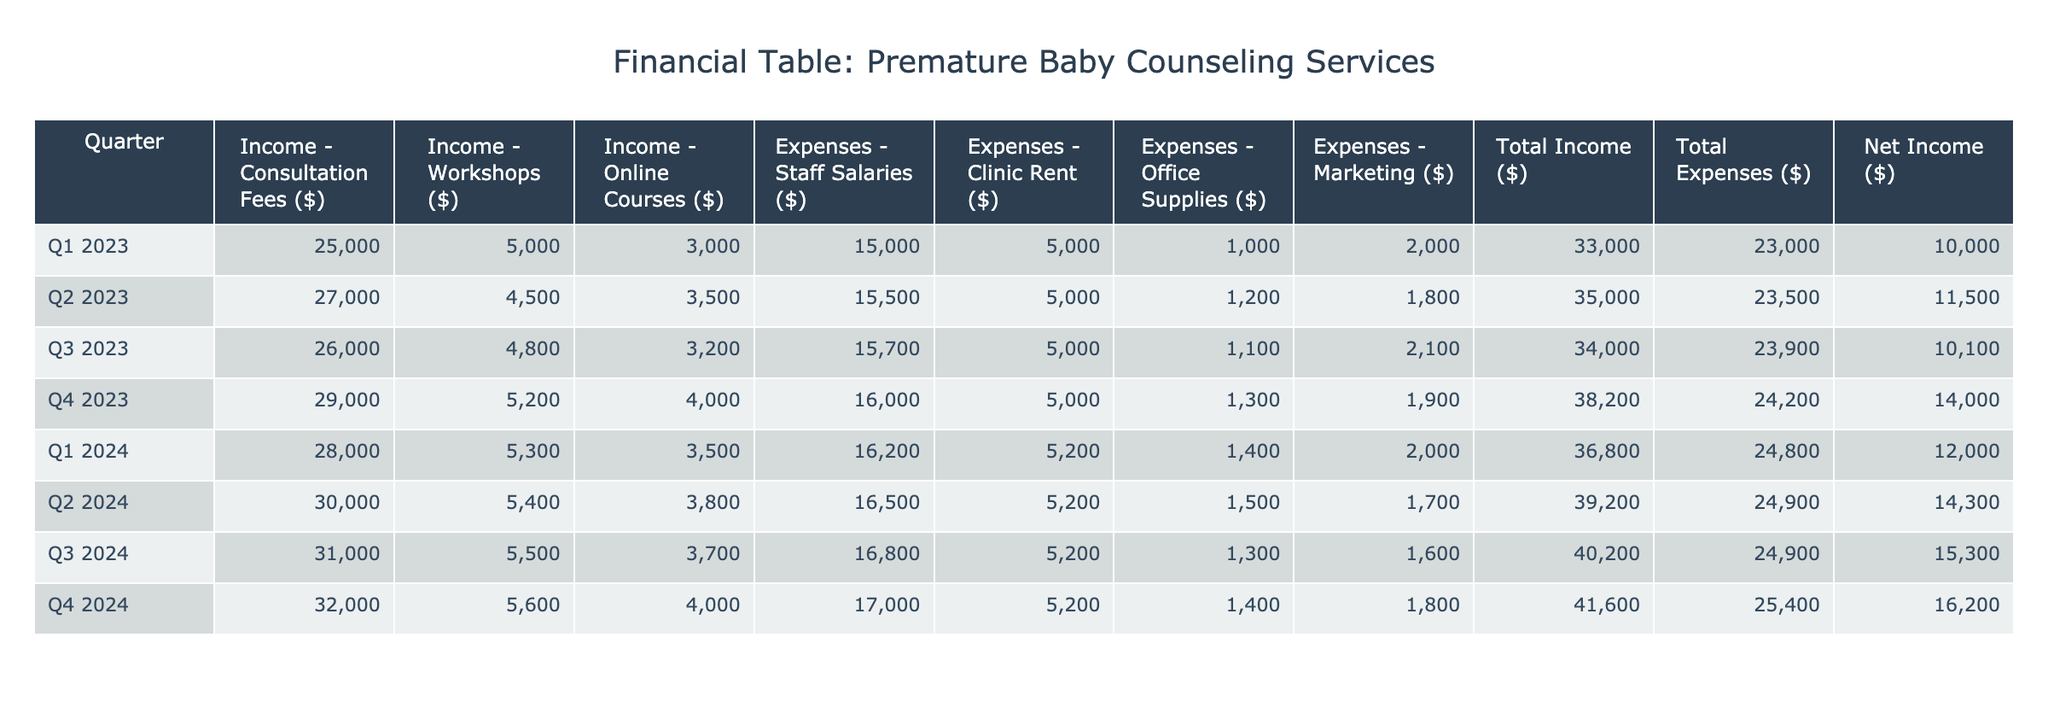What was the total income in Q3 2023? To find the total income in Q3 2023, look at the column labeled "Total Income ($)" and find the row for Q3 2023. The total income listed is 34000.
Answer: 34000 In which quarter did the counseling services have the highest net income? To find the highest net income, compare values in the "Net Income ($)" column across all quarters. The highest value is 16200 in Q4 2024.
Answer: Q4 2024 What is the average expense on office supplies across all quarters? Add the office supplies expenses for each quarter: (1000 + 1200 + 1100 + 1300 + 1400 + 1500 + 1300 + 1400) = 10500. There are 8 quarters, so divide by 8: 10500/8 = 1312.5.
Answer: 1312.5 Did income from workshops increase from Q1 2023 to Q4 2024? Compare the workshops income from Q1 2023 (5000) and Q4 2024 (5600). Since 5600 is greater than 5000, this is true.
Answer: Yes What was the total expense for staff salaries in 2023? To find total expenses of staff salaries for 2023, add the values: 15000 (Q1) + 15500 (Q2) + 15700 (Q3) + 16000 (Q4) = 62200.
Answer: 62200 Which quarter had the lowest total income, and what was that amount? Check the "Total Income ($)" column across the quarters. The lowest income is in Q1 2023, which amounts to 33000.
Answer: Q1 2023, 33000 What was the net income for Q2 2024, and how does it compare to Q1 2024? The net income for Q2 2024 is 14300, and for Q1 2024 it is 12000. Compare them: 14300 is greater than 12000.
Answer: Q2 2024: 14300, higher than Q1 2024: 12000 What percentage of total income did expenses represent in Q3 2023? First, identify total income in Q3 2023 (34000) and total expenses (23900). Calculate percentage: (23900 / 34000) * 100 ≈ 70.59%.
Answer: 70.59% 